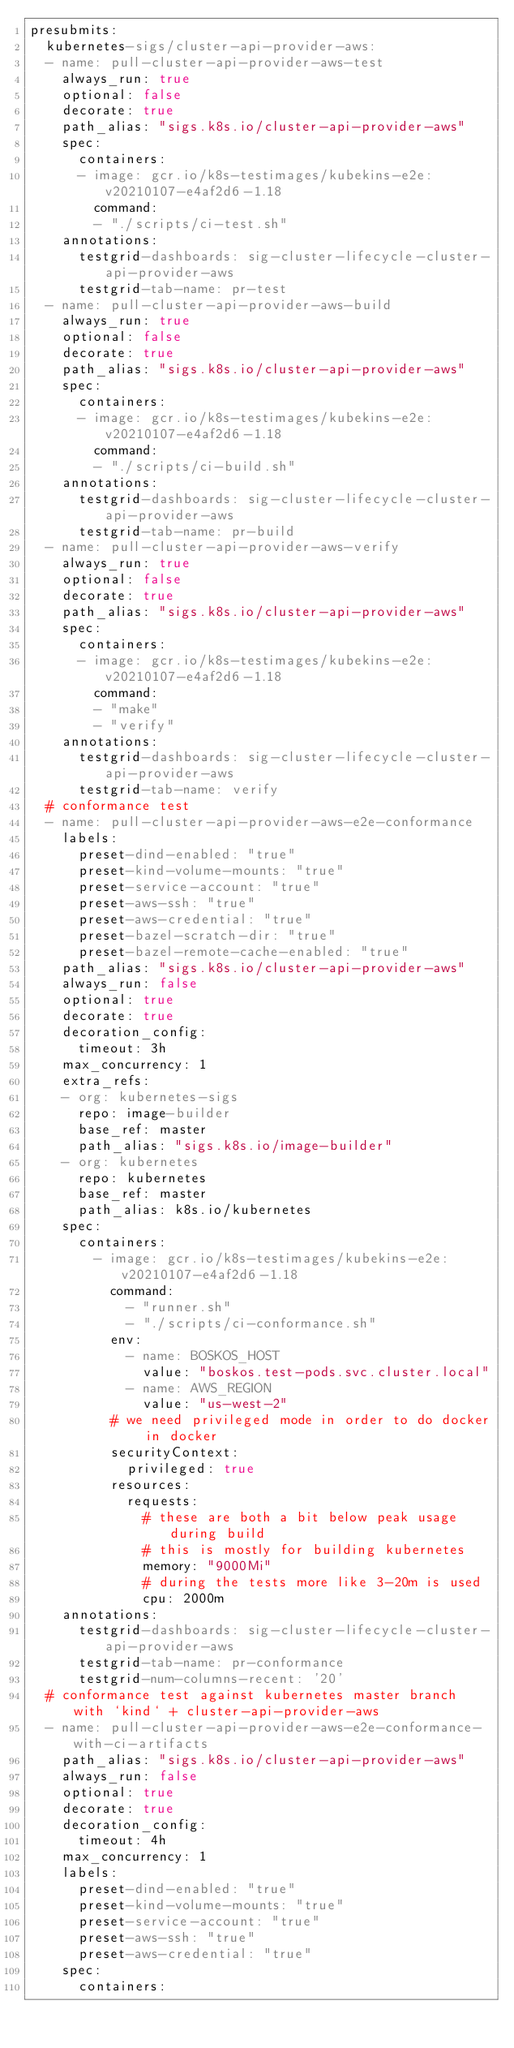<code> <loc_0><loc_0><loc_500><loc_500><_YAML_>presubmits:
  kubernetes-sigs/cluster-api-provider-aws:
  - name: pull-cluster-api-provider-aws-test
    always_run: true
    optional: false
    decorate: true
    path_alias: "sigs.k8s.io/cluster-api-provider-aws"
    spec:
      containers:
      - image: gcr.io/k8s-testimages/kubekins-e2e:v20210107-e4af2d6-1.18
        command:
        - "./scripts/ci-test.sh"
    annotations:
      testgrid-dashboards: sig-cluster-lifecycle-cluster-api-provider-aws
      testgrid-tab-name: pr-test
  - name: pull-cluster-api-provider-aws-build
    always_run: true
    optional: false
    decorate: true
    path_alias: "sigs.k8s.io/cluster-api-provider-aws"
    spec:
      containers:
      - image: gcr.io/k8s-testimages/kubekins-e2e:v20210107-e4af2d6-1.18
        command:
        - "./scripts/ci-build.sh"
    annotations:
      testgrid-dashboards: sig-cluster-lifecycle-cluster-api-provider-aws
      testgrid-tab-name: pr-build
  - name: pull-cluster-api-provider-aws-verify
    always_run: true
    optional: false
    decorate: true
    path_alias: "sigs.k8s.io/cluster-api-provider-aws"
    spec:
      containers:
      - image: gcr.io/k8s-testimages/kubekins-e2e:v20210107-e4af2d6-1.18
        command:
        - "make"
        - "verify"
    annotations:
      testgrid-dashboards: sig-cluster-lifecycle-cluster-api-provider-aws
      testgrid-tab-name: verify
  # conformance test
  - name: pull-cluster-api-provider-aws-e2e-conformance
    labels:
      preset-dind-enabled: "true"
      preset-kind-volume-mounts: "true"
      preset-service-account: "true"
      preset-aws-ssh: "true"
      preset-aws-credential: "true"
      preset-bazel-scratch-dir: "true"
      preset-bazel-remote-cache-enabled: "true"
    path_alias: "sigs.k8s.io/cluster-api-provider-aws"
    always_run: false
    optional: true
    decorate: true
    decoration_config:
      timeout: 3h
    max_concurrency: 1
    extra_refs:
    - org: kubernetes-sigs
      repo: image-builder
      base_ref: master
      path_alias: "sigs.k8s.io/image-builder"
    - org: kubernetes
      repo: kubernetes
      base_ref: master
      path_alias: k8s.io/kubernetes
    spec:
      containers:
        - image: gcr.io/k8s-testimages/kubekins-e2e:v20210107-e4af2d6-1.18
          command:
            - "runner.sh"
            - "./scripts/ci-conformance.sh"
          env:
            - name: BOSKOS_HOST
              value: "boskos.test-pods.svc.cluster.local"
            - name: AWS_REGION
              value: "us-west-2"
          # we need privileged mode in order to do docker in docker
          securityContext:
            privileged: true
          resources:
            requests:
              # these are both a bit below peak usage during build
              # this is mostly for building kubernetes
              memory: "9000Mi"
              # during the tests more like 3-20m is used
              cpu: 2000m
    annotations:
      testgrid-dashboards: sig-cluster-lifecycle-cluster-api-provider-aws
      testgrid-tab-name: pr-conformance
      testgrid-num-columns-recent: '20'
  # conformance test against kubernetes master branch with `kind` + cluster-api-provider-aws
  - name: pull-cluster-api-provider-aws-e2e-conformance-with-ci-artifacts
    path_alias: "sigs.k8s.io/cluster-api-provider-aws"
    always_run: false
    optional: true
    decorate: true
    decoration_config:
      timeout: 4h
    max_concurrency: 1
    labels:
      preset-dind-enabled: "true"
      preset-kind-volume-mounts: "true"
      preset-service-account: "true"
      preset-aws-ssh: "true"
      preset-aws-credential: "true"
    spec:
      containers:</code> 